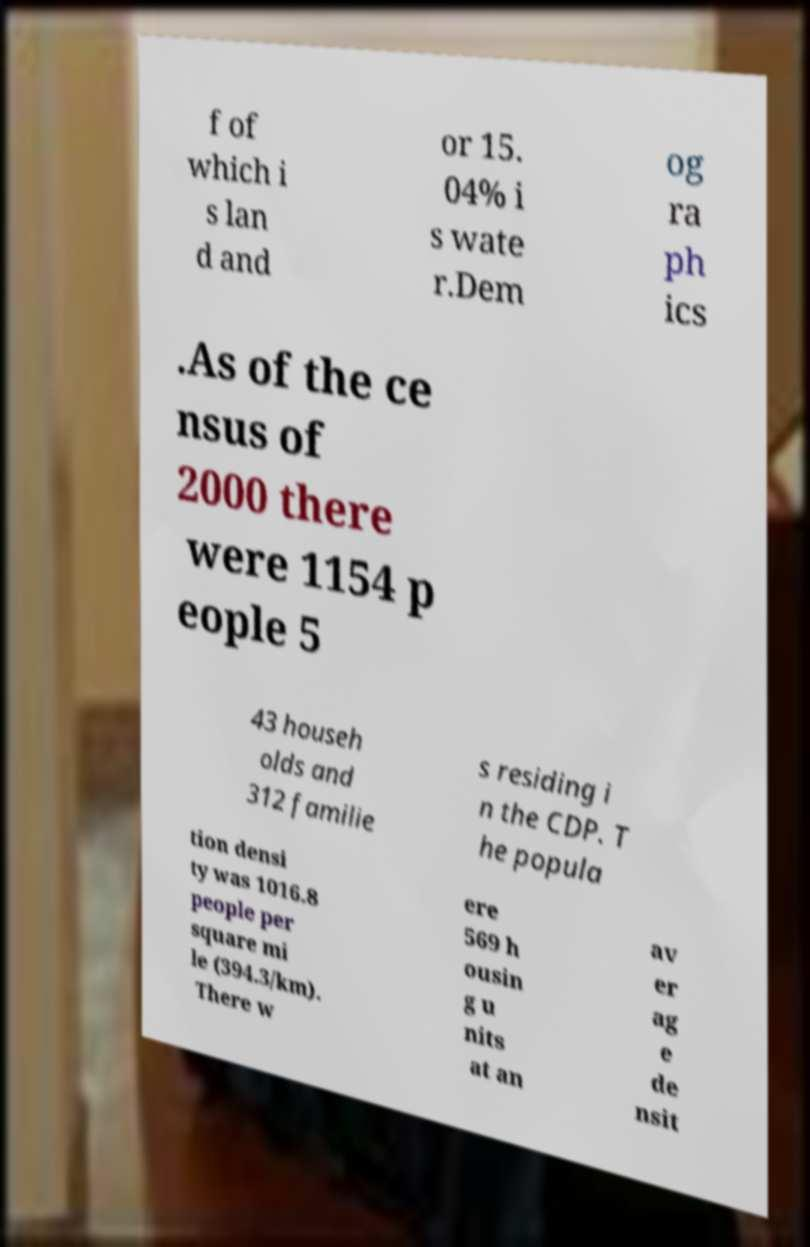Can you accurately transcribe the text from the provided image for me? f of which i s lan d and or 15. 04% i s wate r.Dem og ra ph ics .As of the ce nsus of 2000 there were 1154 p eople 5 43 househ olds and 312 familie s residing i n the CDP. T he popula tion densi ty was 1016.8 people per square mi le (394.3/km). There w ere 569 h ousin g u nits at an av er ag e de nsit 